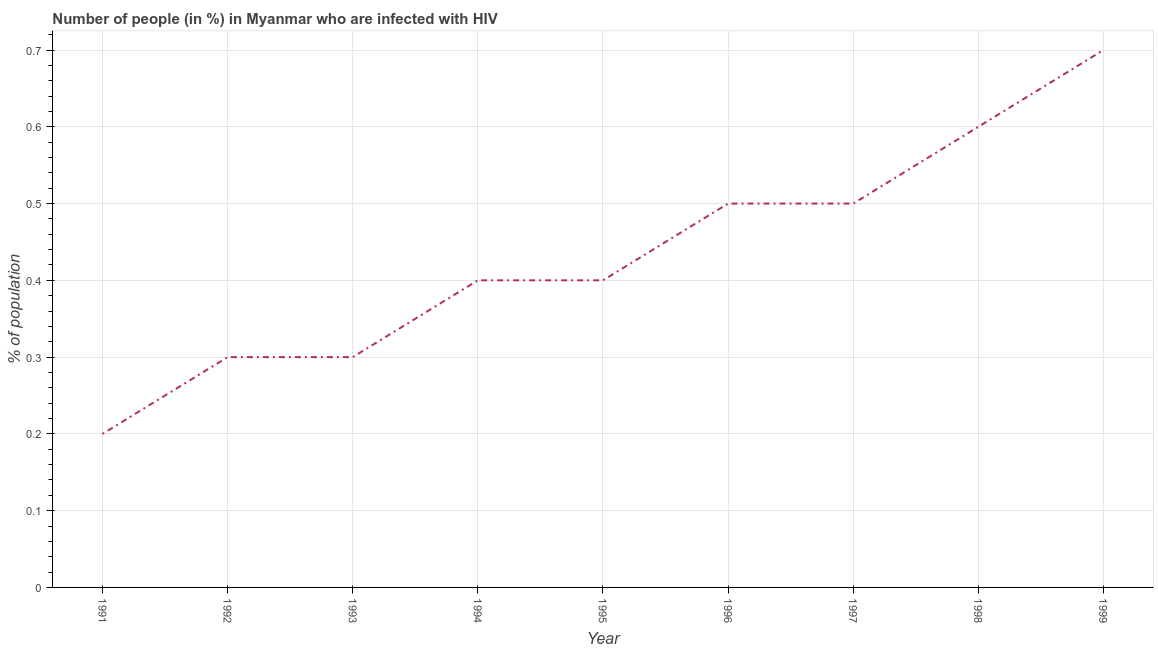What is the number of people infected with hiv in 1992?
Provide a short and direct response. 0.3. In which year was the number of people infected with hiv maximum?
Ensure brevity in your answer.  1999. In which year was the number of people infected with hiv minimum?
Ensure brevity in your answer.  1991. What is the sum of the number of people infected with hiv?
Make the answer very short. 3.9. What is the difference between the number of people infected with hiv in 1995 and 1998?
Give a very brief answer. -0.2. What is the average number of people infected with hiv per year?
Your answer should be compact. 0.43. What is the median number of people infected with hiv?
Provide a short and direct response. 0.4. In how many years, is the number of people infected with hiv greater than 0.08 %?
Make the answer very short. 9. What is the ratio of the number of people infected with hiv in 1995 to that in 1997?
Provide a short and direct response. 0.8. Is the number of people infected with hiv in 1991 less than that in 1999?
Keep it short and to the point. Yes. Is the difference between the number of people infected with hiv in 1993 and 1996 greater than the difference between any two years?
Give a very brief answer. No. What is the difference between the highest and the second highest number of people infected with hiv?
Ensure brevity in your answer.  0.1. Is the sum of the number of people infected with hiv in 1991 and 1992 greater than the maximum number of people infected with hiv across all years?
Offer a very short reply. No. What is the difference between the highest and the lowest number of people infected with hiv?
Keep it short and to the point. 0.5. In how many years, is the number of people infected with hiv greater than the average number of people infected with hiv taken over all years?
Offer a very short reply. 4. What is the difference between two consecutive major ticks on the Y-axis?
Your response must be concise. 0.1. Are the values on the major ticks of Y-axis written in scientific E-notation?
Give a very brief answer. No. What is the title of the graph?
Offer a terse response. Number of people (in %) in Myanmar who are infected with HIV. What is the label or title of the Y-axis?
Offer a terse response. % of population. What is the % of population in 1992?
Offer a very short reply. 0.3. What is the % of population of 1994?
Give a very brief answer. 0.4. What is the % of population of 1996?
Your response must be concise. 0.5. What is the % of population of 1997?
Provide a succinct answer. 0.5. What is the % of population of 1998?
Ensure brevity in your answer.  0.6. What is the difference between the % of population in 1991 and 1996?
Provide a succinct answer. -0.3. What is the difference between the % of population in 1991 and 1998?
Offer a terse response. -0.4. What is the difference between the % of population in 1991 and 1999?
Make the answer very short. -0.5. What is the difference between the % of population in 1992 and 1993?
Your response must be concise. 0. What is the difference between the % of population in 1992 and 1994?
Your answer should be very brief. -0.1. What is the difference between the % of population in 1992 and 1995?
Keep it short and to the point. -0.1. What is the difference between the % of population in 1992 and 1996?
Offer a very short reply. -0.2. What is the difference between the % of population in 1992 and 1997?
Keep it short and to the point. -0.2. What is the difference between the % of population in 1992 and 1999?
Provide a succinct answer. -0.4. What is the difference between the % of population in 1993 and 1995?
Provide a succinct answer. -0.1. What is the difference between the % of population in 1993 and 1998?
Offer a very short reply. -0.3. What is the difference between the % of population in 1994 and 1996?
Make the answer very short. -0.1. What is the difference between the % of population in 1995 and 1996?
Keep it short and to the point. -0.1. What is the difference between the % of population in 1995 and 1998?
Provide a succinct answer. -0.2. What is the difference between the % of population in 1995 and 1999?
Keep it short and to the point. -0.3. What is the difference between the % of population in 1996 and 1999?
Keep it short and to the point. -0.2. What is the difference between the % of population in 1997 and 1999?
Your response must be concise. -0.2. What is the difference between the % of population in 1998 and 1999?
Offer a very short reply. -0.1. What is the ratio of the % of population in 1991 to that in 1992?
Give a very brief answer. 0.67. What is the ratio of the % of population in 1991 to that in 1993?
Your answer should be very brief. 0.67. What is the ratio of the % of population in 1991 to that in 1994?
Your response must be concise. 0.5. What is the ratio of the % of population in 1991 to that in 1997?
Offer a terse response. 0.4. What is the ratio of the % of population in 1991 to that in 1998?
Offer a terse response. 0.33. What is the ratio of the % of population in 1991 to that in 1999?
Offer a very short reply. 0.29. What is the ratio of the % of population in 1992 to that in 1998?
Offer a terse response. 0.5. What is the ratio of the % of population in 1992 to that in 1999?
Your answer should be compact. 0.43. What is the ratio of the % of population in 1993 to that in 1996?
Offer a terse response. 0.6. What is the ratio of the % of population in 1993 to that in 1998?
Keep it short and to the point. 0.5. What is the ratio of the % of population in 1993 to that in 1999?
Ensure brevity in your answer.  0.43. What is the ratio of the % of population in 1994 to that in 1996?
Your answer should be very brief. 0.8. What is the ratio of the % of population in 1994 to that in 1997?
Offer a terse response. 0.8. What is the ratio of the % of population in 1994 to that in 1998?
Offer a terse response. 0.67. What is the ratio of the % of population in 1994 to that in 1999?
Offer a very short reply. 0.57. What is the ratio of the % of population in 1995 to that in 1996?
Your answer should be very brief. 0.8. What is the ratio of the % of population in 1995 to that in 1998?
Your answer should be very brief. 0.67. What is the ratio of the % of population in 1995 to that in 1999?
Ensure brevity in your answer.  0.57. What is the ratio of the % of population in 1996 to that in 1997?
Your answer should be very brief. 1. What is the ratio of the % of population in 1996 to that in 1998?
Your response must be concise. 0.83. What is the ratio of the % of population in 1996 to that in 1999?
Your answer should be compact. 0.71. What is the ratio of the % of population in 1997 to that in 1998?
Your response must be concise. 0.83. What is the ratio of the % of population in 1997 to that in 1999?
Offer a terse response. 0.71. What is the ratio of the % of population in 1998 to that in 1999?
Give a very brief answer. 0.86. 